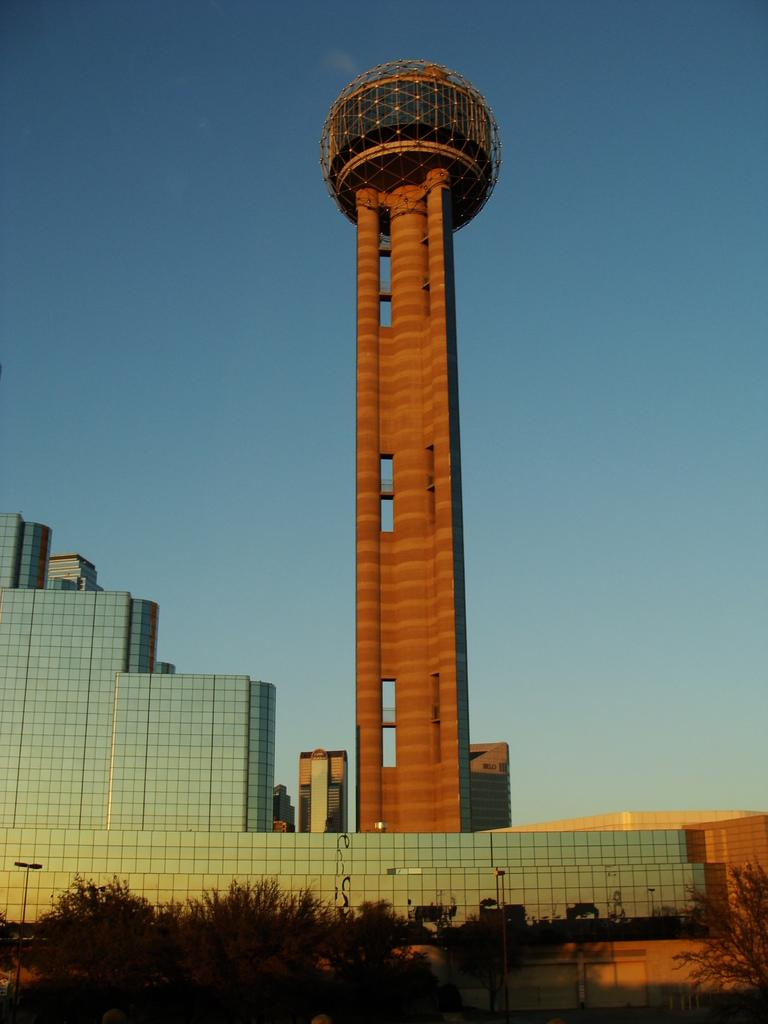What is the main structure in the image? There is a tower in the image. What other large structure is near the tower? There is a big building beside the tower. What type of vegetation is in front of the building? There are many trees in front of the building. What type of lace can be seen on the windows of the building in the image? There is no mention of lace or windows on the building in the image, so it cannot be determined from the image. 